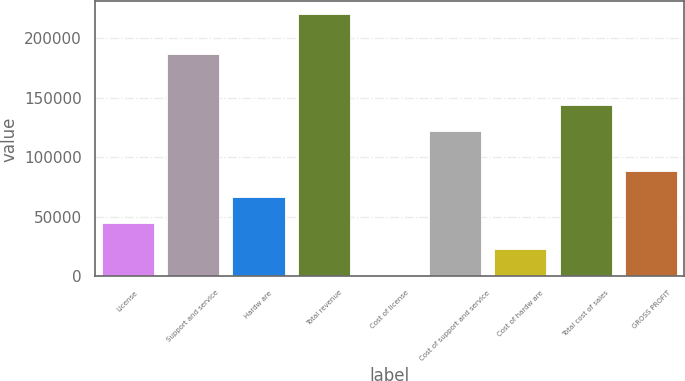Convert chart to OTSL. <chart><loc_0><loc_0><loc_500><loc_500><bar_chart><fcel>License<fcel>Support and service<fcel>Hardw are<fcel>Total revenue<fcel>Cost of license<fcel>Cost of support and service<fcel>Cost of hardw are<fcel>Total cost of sales<fcel>GROSS PROFIT<nl><fcel>45022.6<fcel>186956<fcel>66895.4<fcel>220005<fcel>1277<fcel>121877<fcel>23149.8<fcel>143750<fcel>88768.2<nl></chart> 